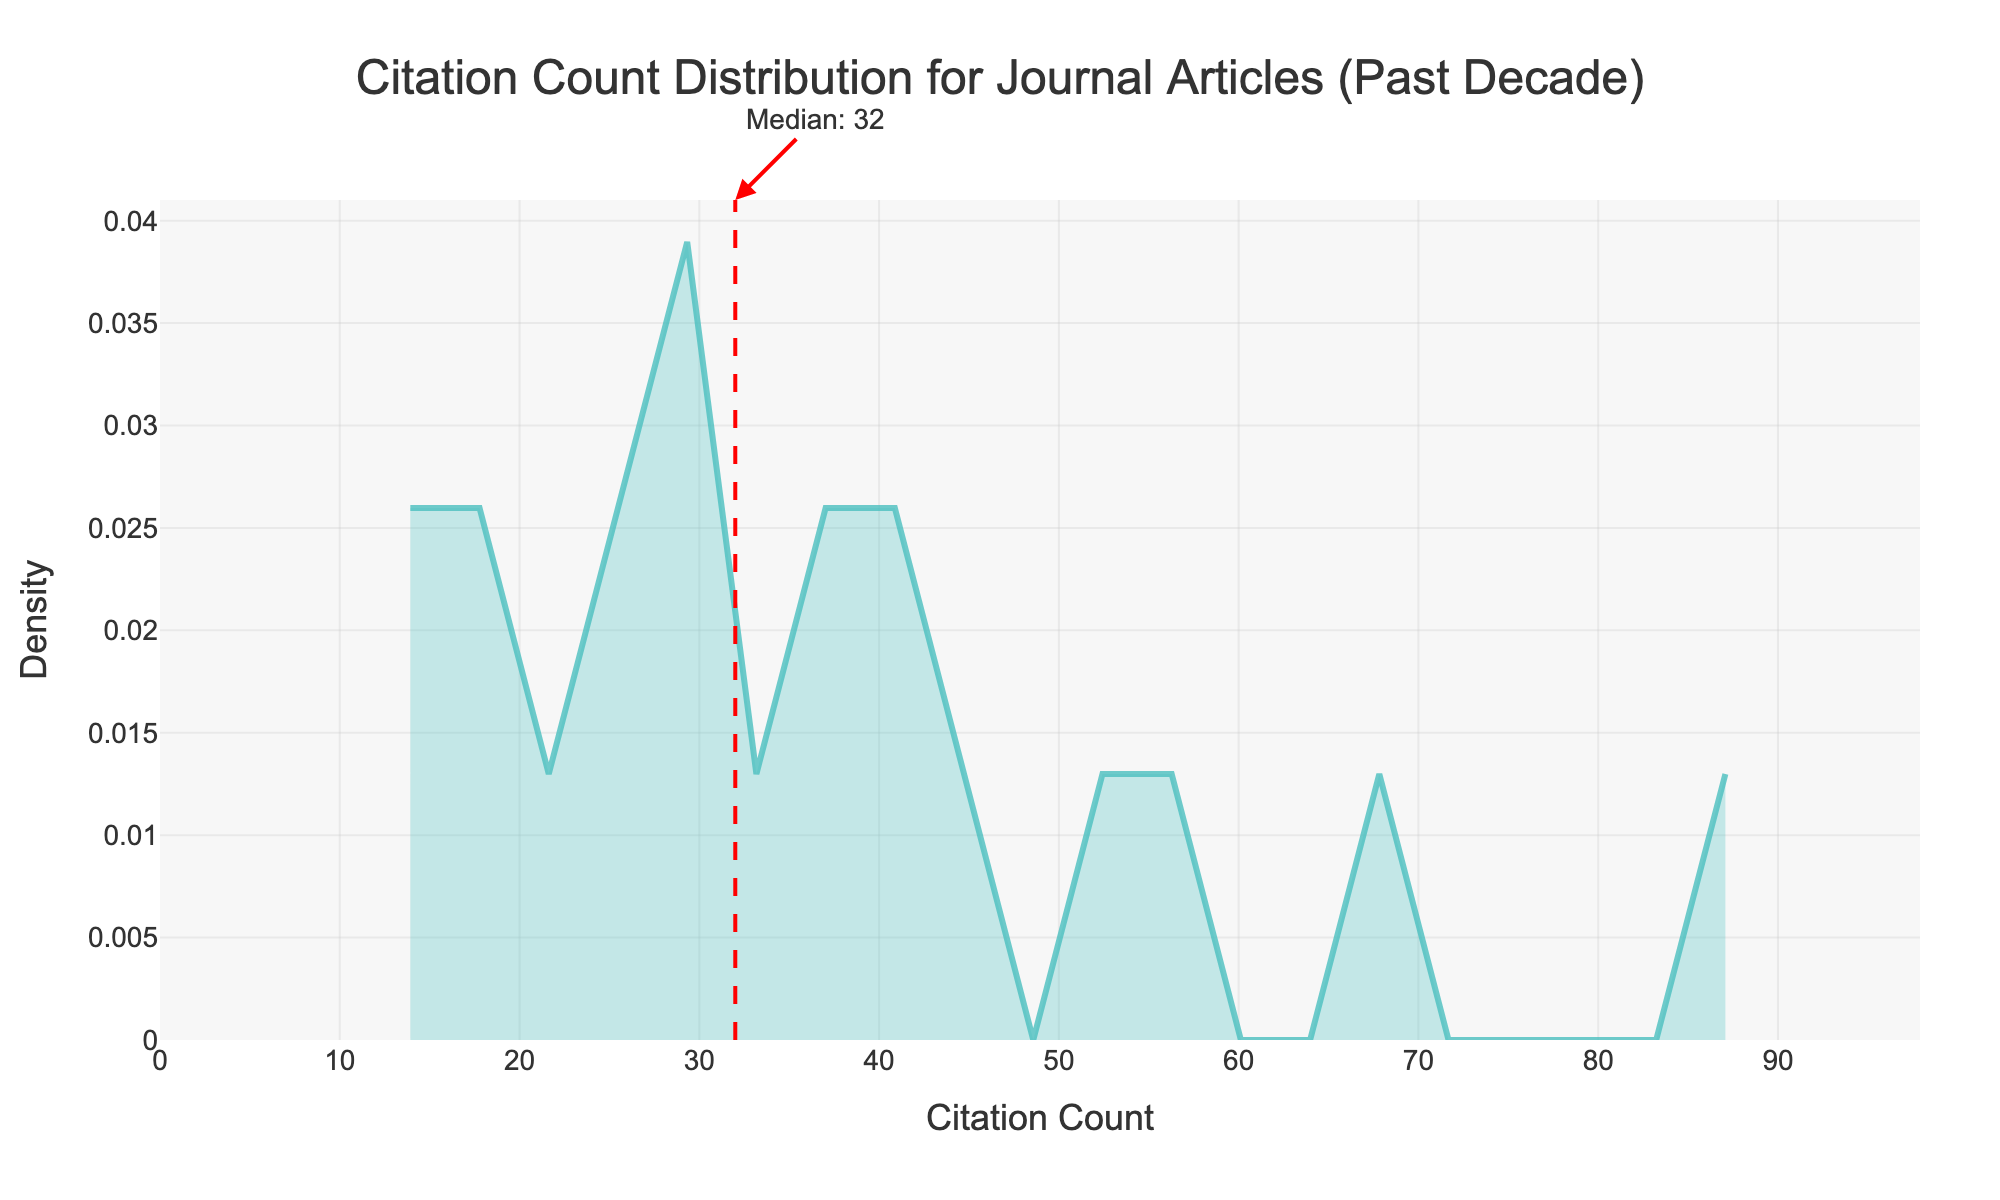What is the title of the density plot? The title is positioned at the top of the figure. It reads 'Citation Count Distribution for Journal Articles (Past Decade)'.
Answer: Citation Count Distribution for Journal Articles (Past Decade) What do the x-axis and y-axis represent? The x-axis represents the Citation Count, and the y-axis represents the Density, as indicated by the axis titles.
Answer: x-axis: Citation Count, y-axis: Density What is the color of the density line? The density line is depicted in a shade of green-blue, as observed from the figure.
Answer: Green-blue What value does the dashed red line represent? The dashed red line marks the median Citation Count value, which is indicated by the annotation next to the line.
Answer: Median What is the median citation count? The median citation count is given by the annotation on the plot pointing to the dashed red line, which states 'Median: 30'.
Answer: 30 What is the highest citation count on the x-axis? The x-axis range is from 0 to a bit more than the maximum value in the data. Observing the end of the axis, the highest citation count is approximately around 100.
Answer: Approximately 100 Compare the density at 20 and 70 citation counts. Which is higher? By examining the height of the density curve at Citation Count 20 and 70, we observe that the density at 20 is higher than that at 70.
Answer: Density at 20 To what value does the density curve drop the lowest within the visible range? Observing the density curve closely, it appears to drop the lowest just above 80 citation counts before increasing slightly towards the end.
Answer: Just above 80 Interpret the density area between the 10 and 30 citation counts. Is it more populated compared to 50-70? The density area between 10 and 30 citation counts has a higher density compared to the area between 50 and 70 citation counts, meaning it is more populated.
Answer: More populated 